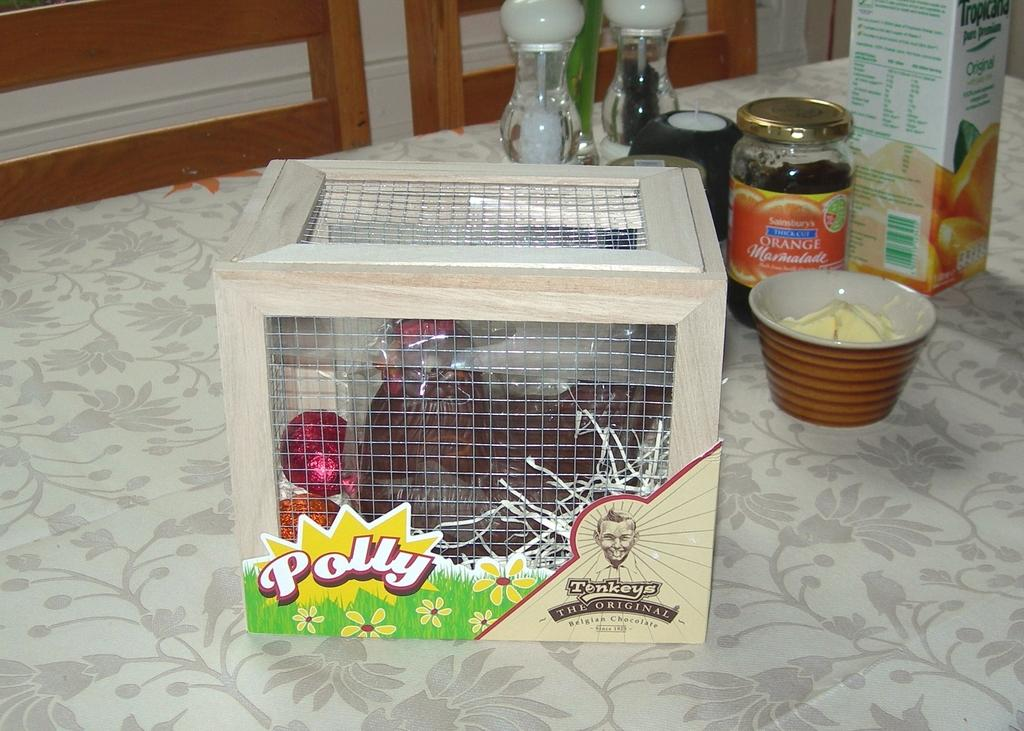<image>
Render a clear and concise summary of the photo. A box with the name Polly and the original Belgium chocolate is on the front. 